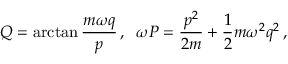Convert formula to latex. <formula><loc_0><loc_0><loc_500><loc_500>Q = \arctan \frac { m \omega q } { p } \, , \, \omega P = \frac { p ^ { 2 } } { 2 m } + \frac { 1 } { 2 } m \omega ^ { 2 } q ^ { 2 } \, ,</formula> 